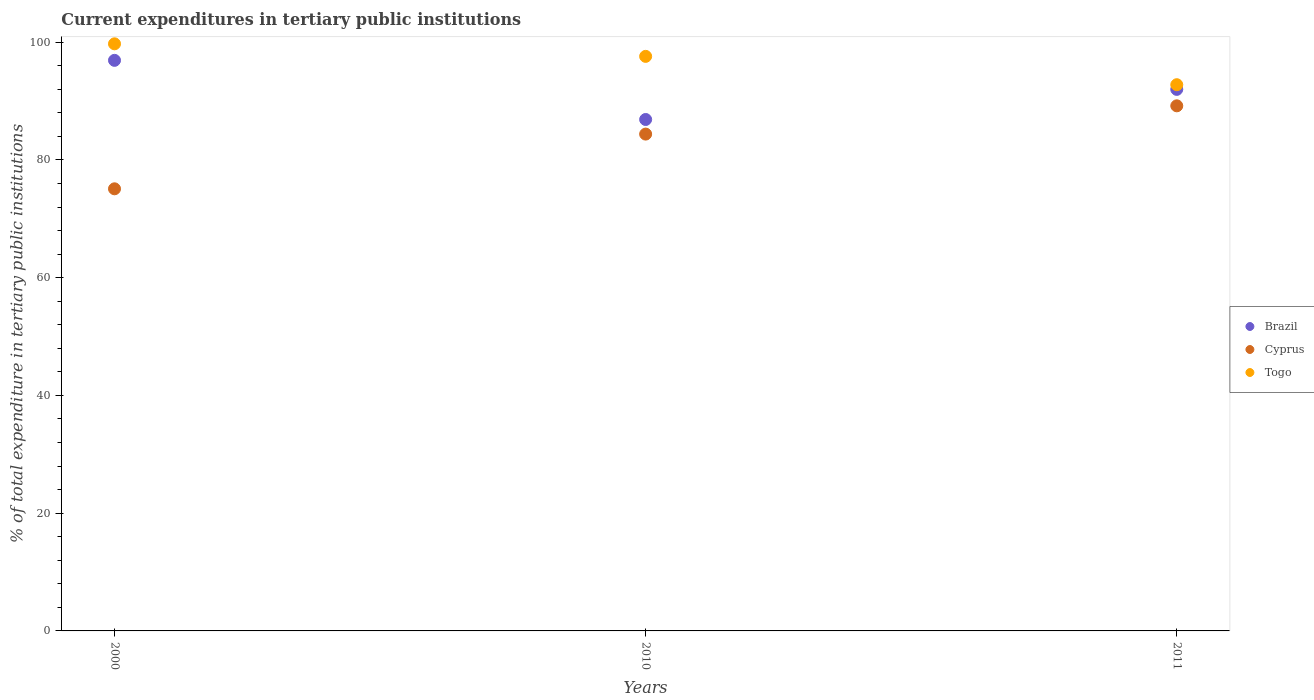Is the number of dotlines equal to the number of legend labels?
Your answer should be very brief. Yes. What is the current expenditures in tertiary public institutions in Brazil in 2000?
Keep it short and to the point. 96.92. Across all years, what is the maximum current expenditures in tertiary public institutions in Cyprus?
Offer a terse response. 89.19. Across all years, what is the minimum current expenditures in tertiary public institutions in Togo?
Ensure brevity in your answer.  92.78. In which year was the current expenditures in tertiary public institutions in Brazil maximum?
Make the answer very short. 2000. In which year was the current expenditures in tertiary public institutions in Togo minimum?
Give a very brief answer. 2011. What is the total current expenditures in tertiary public institutions in Brazil in the graph?
Your answer should be compact. 275.77. What is the difference between the current expenditures in tertiary public institutions in Brazil in 2010 and that in 2011?
Offer a terse response. -5.11. What is the difference between the current expenditures in tertiary public institutions in Togo in 2011 and the current expenditures in tertiary public institutions in Brazil in 2010?
Provide a succinct answer. 5.91. What is the average current expenditures in tertiary public institutions in Togo per year?
Offer a terse response. 96.7. In the year 2011, what is the difference between the current expenditures in tertiary public institutions in Cyprus and current expenditures in tertiary public institutions in Brazil?
Your answer should be very brief. -2.79. What is the ratio of the current expenditures in tertiary public institutions in Cyprus in 2000 to that in 2010?
Provide a short and direct response. 0.89. Is the current expenditures in tertiary public institutions in Togo in 2000 less than that in 2011?
Give a very brief answer. No. Is the difference between the current expenditures in tertiary public institutions in Cyprus in 2000 and 2011 greater than the difference between the current expenditures in tertiary public institutions in Brazil in 2000 and 2011?
Your answer should be very brief. No. What is the difference between the highest and the second highest current expenditures in tertiary public institutions in Cyprus?
Offer a very short reply. 4.8. What is the difference between the highest and the lowest current expenditures in tertiary public institutions in Brazil?
Provide a short and direct response. 10.05. Is the sum of the current expenditures in tertiary public institutions in Togo in 2010 and 2011 greater than the maximum current expenditures in tertiary public institutions in Brazil across all years?
Make the answer very short. Yes. Is the current expenditures in tertiary public institutions in Cyprus strictly greater than the current expenditures in tertiary public institutions in Brazil over the years?
Offer a very short reply. No. Is the current expenditures in tertiary public institutions in Brazil strictly less than the current expenditures in tertiary public institutions in Cyprus over the years?
Make the answer very short. No. How many dotlines are there?
Give a very brief answer. 3. How many years are there in the graph?
Offer a very short reply. 3. Does the graph contain grids?
Give a very brief answer. No. Where does the legend appear in the graph?
Make the answer very short. Center right. How are the legend labels stacked?
Your answer should be compact. Vertical. What is the title of the graph?
Your response must be concise. Current expenditures in tertiary public institutions. Does "Guinea" appear as one of the legend labels in the graph?
Offer a very short reply. No. What is the label or title of the Y-axis?
Offer a very short reply. % of total expenditure in tertiary public institutions. What is the % of total expenditure in tertiary public institutions of Brazil in 2000?
Your response must be concise. 96.92. What is the % of total expenditure in tertiary public institutions in Cyprus in 2000?
Offer a terse response. 75.1. What is the % of total expenditure in tertiary public institutions in Togo in 2000?
Your answer should be very brief. 99.72. What is the % of total expenditure in tertiary public institutions of Brazil in 2010?
Provide a succinct answer. 86.87. What is the % of total expenditure in tertiary public institutions in Cyprus in 2010?
Your response must be concise. 84.39. What is the % of total expenditure in tertiary public institutions of Togo in 2010?
Make the answer very short. 97.59. What is the % of total expenditure in tertiary public institutions in Brazil in 2011?
Make the answer very short. 91.99. What is the % of total expenditure in tertiary public institutions of Cyprus in 2011?
Give a very brief answer. 89.19. What is the % of total expenditure in tertiary public institutions of Togo in 2011?
Ensure brevity in your answer.  92.78. Across all years, what is the maximum % of total expenditure in tertiary public institutions of Brazil?
Ensure brevity in your answer.  96.92. Across all years, what is the maximum % of total expenditure in tertiary public institutions of Cyprus?
Your answer should be compact. 89.19. Across all years, what is the maximum % of total expenditure in tertiary public institutions in Togo?
Keep it short and to the point. 99.72. Across all years, what is the minimum % of total expenditure in tertiary public institutions in Brazil?
Your answer should be very brief. 86.87. Across all years, what is the minimum % of total expenditure in tertiary public institutions in Cyprus?
Ensure brevity in your answer.  75.1. Across all years, what is the minimum % of total expenditure in tertiary public institutions of Togo?
Your response must be concise. 92.78. What is the total % of total expenditure in tertiary public institutions in Brazil in the graph?
Provide a succinct answer. 275.77. What is the total % of total expenditure in tertiary public institutions of Cyprus in the graph?
Provide a succinct answer. 248.68. What is the total % of total expenditure in tertiary public institutions in Togo in the graph?
Give a very brief answer. 290.09. What is the difference between the % of total expenditure in tertiary public institutions in Brazil in 2000 and that in 2010?
Provide a succinct answer. 10.05. What is the difference between the % of total expenditure in tertiary public institutions of Cyprus in 2000 and that in 2010?
Give a very brief answer. -9.29. What is the difference between the % of total expenditure in tertiary public institutions in Togo in 2000 and that in 2010?
Offer a terse response. 2.13. What is the difference between the % of total expenditure in tertiary public institutions of Brazil in 2000 and that in 2011?
Your answer should be compact. 4.93. What is the difference between the % of total expenditure in tertiary public institutions of Cyprus in 2000 and that in 2011?
Your answer should be very brief. -14.1. What is the difference between the % of total expenditure in tertiary public institutions in Togo in 2000 and that in 2011?
Keep it short and to the point. 6.95. What is the difference between the % of total expenditure in tertiary public institutions in Brazil in 2010 and that in 2011?
Your response must be concise. -5.11. What is the difference between the % of total expenditure in tertiary public institutions of Cyprus in 2010 and that in 2011?
Keep it short and to the point. -4.8. What is the difference between the % of total expenditure in tertiary public institutions in Togo in 2010 and that in 2011?
Your answer should be compact. 4.81. What is the difference between the % of total expenditure in tertiary public institutions of Brazil in 2000 and the % of total expenditure in tertiary public institutions of Cyprus in 2010?
Provide a succinct answer. 12.53. What is the difference between the % of total expenditure in tertiary public institutions in Brazil in 2000 and the % of total expenditure in tertiary public institutions in Togo in 2010?
Make the answer very short. -0.68. What is the difference between the % of total expenditure in tertiary public institutions of Cyprus in 2000 and the % of total expenditure in tertiary public institutions of Togo in 2010?
Offer a terse response. -22.5. What is the difference between the % of total expenditure in tertiary public institutions in Brazil in 2000 and the % of total expenditure in tertiary public institutions in Cyprus in 2011?
Give a very brief answer. 7.72. What is the difference between the % of total expenditure in tertiary public institutions in Brazil in 2000 and the % of total expenditure in tertiary public institutions in Togo in 2011?
Make the answer very short. 4.14. What is the difference between the % of total expenditure in tertiary public institutions of Cyprus in 2000 and the % of total expenditure in tertiary public institutions of Togo in 2011?
Provide a succinct answer. -17.68. What is the difference between the % of total expenditure in tertiary public institutions of Brazil in 2010 and the % of total expenditure in tertiary public institutions of Cyprus in 2011?
Your response must be concise. -2.32. What is the difference between the % of total expenditure in tertiary public institutions in Brazil in 2010 and the % of total expenditure in tertiary public institutions in Togo in 2011?
Ensure brevity in your answer.  -5.91. What is the difference between the % of total expenditure in tertiary public institutions in Cyprus in 2010 and the % of total expenditure in tertiary public institutions in Togo in 2011?
Ensure brevity in your answer.  -8.39. What is the average % of total expenditure in tertiary public institutions in Brazil per year?
Offer a very short reply. 91.92. What is the average % of total expenditure in tertiary public institutions in Cyprus per year?
Ensure brevity in your answer.  82.89. What is the average % of total expenditure in tertiary public institutions of Togo per year?
Provide a short and direct response. 96.7. In the year 2000, what is the difference between the % of total expenditure in tertiary public institutions of Brazil and % of total expenditure in tertiary public institutions of Cyprus?
Give a very brief answer. 21.82. In the year 2000, what is the difference between the % of total expenditure in tertiary public institutions in Brazil and % of total expenditure in tertiary public institutions in Togo?
Offer a terse response. -2.81. In the year 2000, what is the difference between the % of total expenditure in tertiary public institutions of Cyprus and % of total expenditure in tertiary public institutions of Togo?
Give a very brief answer. -24.63. In the year 2010, what is the difference between the % of total expenditure in tertiary public institutions of Brazil and % of total expenditure in tertiary public institutions of Cyprus?
Your answer should be compact. 2.48. In the year 2010, what is the difference between the % of total expenditure in tertiary public institutions of Brazil and % of total expenditure in tertiary public institutions of Togo?
Make the answer very short. -10.72. In the year 2010, what is the difference between the % of total expenditure in tertiary public institutions in Cyprus and % of total expenditure in tertiary public institutions in Togo?
Your answer should be very brief. -13.2. In the year 2011, what is the difference between the % of total expenditure in tertiary public institutions in Brazil and % of total expenditure in tertiary public institutions in Cyprus?
Provide a short and direct response. 2.79. In the year 2011, what is the difference between the % of total expenditure in tertiary public institutions of Brazil and % of total expenditure in tertiary public institutions of Togo?
Offer a terse response. -0.79. In the year 2011, what is the difference between the % of total expenditure in tertiary public institutions of Cyprus and % of total expenditure in tertiary public institutions of Togo?
Your answer should be compact. -3.59. What is the ratio of the % of total expenditure in tertiary public institutions of Brazil in 2000 to that in 2010?
Offer a terse response. 1.12. What is the ratio of the % of total expenditure in tertiary public institutions in Cyprus in 2000 to that in 2010?
Provide a short and direct response. 0.89. What is the ratio of the % of total expenditure in tertiary public institutions of Togo in 2000 to that in 2010?
Provide a short and direct response. 1.02. What is the ratio of the % of total expenditure in tertiary public institutions in Brazil in 2000 to that in 2011?
Your response must be concise. 1.05. What is the ratio of the % of total expenditure in tertiary public institutions of Cyprus in 2000 to that in 2011?
Your answer should be very brief. 0.84. What is the ratio of the % of total expenditure in tertiary public institutions of Togo in 2000 to that in 2011?
Provide a succinct answer. 1.07. What is the ratio of the % of total expenditure in tertiary public institutions of Brazil in 2010 to that in 2011?
Provide a succinct answer. 0.94. What is the ratio of the % of total expenditure in tertiary public institutions of Cyprus in 2010 to that in 2011?
Provide a succinct answer. 0.95. What is the ratio of the % of total expenditure in tertiary public institutions of Togo in 2010 to that in 2011?
Your answer should be very brief. 1.05. What is the difference between the highest and the second highest % of total expenditure in tertiary public institutions of Brazil?
Offer a terse response. 4.93. What is the difference between the highest and the second highest % of total expenditure in tertiary public institutions of Cyprus?
Provide a succinct answer. 4.8. What is the difference between the highest and the second highest % of total expenditure in tertiary public institutions in Togo?
Provide a short and direct response. 2.13. What is the difference between the highest and the lowest % of total expenditure in tertiary public institutions of Brazil?
Your answer should be very brief. 10.05. What is the difference between the highest and the lowest % of total expenditure in tertiary public institutions in Cyprus?
Offer a very short reply. 14.1. What is the difference between the highest and the lowest % of total expenditure in tertiary public institutions of Togo?
Your answer should be very brief. 6.95. 